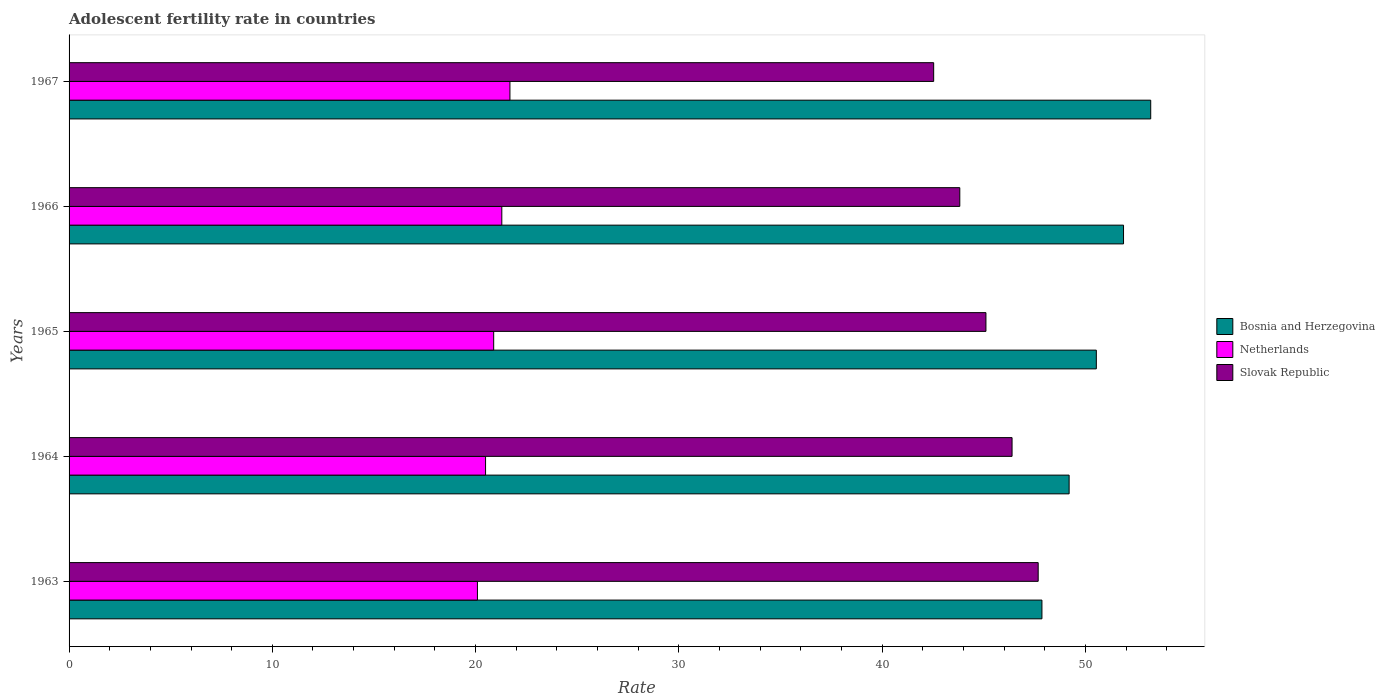Are the number of bars per tick equal to the number of legend labels?
Your response must be concise. Yes. Are the number of bars on each tick of the Y-axis equal?
Give a very brief answer. Yes. How many bars are there on the 5th tick from the bottom?
Offer a very short reply. 3. What is the label of the 4th group of bars from the top?
Your response must be concise. 1964. What is the adolescent fertility rate in Bosnia and Herzegovina in 1966?
Your answer should be compact. 51.88. Across all years, what is the maximum adolescent fertility rate in Slovak Republic?
Offer a terse response. 47.68. Across all years, what is the minimum adolescent fertility rate in Netherlands?
Keep it short and to the point. 20.09. In which year was the adolescent fertility rate in Slovak Republic maximum?
Provide a short and direct response. 1963. In which year was the adolescent fertility rate in Netherlands minimum?
Give a very brief answer. 1963. What is the total adolescent fertility rate in Bosnia and Herzegovina in the graph?
Offer a very short reply. 252.69. What is the difference between the adolescent fertility rate in Netherlands in 1963 and that in 1966?
Give a very brief answer. -1.2. What is the difference between the adolescent fertility rate in Bosnia and Herzegovina in 1966 and the adolescent fertility rate in Netherlands in 1963?
Give a very brief answer. 31.79. What is the average adolescent fertility rate in Slovak Republic per year?
Your answer should be very brief. 45.11. In the year 1964, what is the difference between the adolescent fertility rate in Bosnia and Herzegovina and adolescent fertility rate in Slovak Republic?
Provide a short and direct response. 2.81. What is the ratio of the adolescent fertility rate in Bosnia and Herzegovina in 1964 to that in 1965?
Keep it short and to the point. 0.97. Is the adolescent fertility rate in Slovak Republic in 1963 less than that in 1966?
Provide a succinct answer. No. Is the difference between the adolescent fertility rate in Bosnia and Herzegovina in 1963 and 1965 greater than the difference between the adolescent fertility rate in Slovak Republic in 1963 and 1965?
Provide a succinct answer. No. What is the difference between the highest and the second highest adolescent fertility rate in Slovak Republic?
Ensure brevity in your answer.  1.29. What is the difference between the highest and the lowest adolescent fertility rate in Slovak Republic?
Your response must be concise. 5.14. In how many years, is the adolescent fertility rate in Bosnia and Herzegovina greater than the average adolescent fertility rate in Bosnia and Herzegovina taken over all years?
Provide a succinct answer. 2. Is the sum of the adolescent fertility rate in Bosnia and Herzegovina in 1964 and 1967 greater than the maximum adolescent fertility rate in Netherlands across all years?
Your response must be concise. Yes. What does the 3rd bar from the top in 1963 represents?
Give a very brief answer. Bosnia and Herzegovina. What does the 2nd bar from the bottom in 1965 represents?
Make the answer very short. Netherlands. How many bars are there?
Offer a very short reply. 15. What is the difference between two consecutive major ticks on the X-axis?
Your response must be concise. 10. Are the values on the major ticks of X-axis written in scientific E-notation?
Provide a succinct answer. No. Does the graph contain any zero values?
Keep it short and to the point. No. Does the graph contain grids?
Your answer should be very brief. No. What is the title of the graph?
Offer a terse response. Adolescent fertility rate in countries. Does "Luxembourg" appear as one of the legend labels in the graph?
Offer a terse response. No. What is the label or title of the X-axis?
Your response must be concise. Rate. What is the Rate of Bosnia and Herzegovina in 1963?
Your answer should be compact. 47.86. What is the Rate in Netherlands in 1963?
Offer a terse response. 20.09. What is the Rate of Slovak Republic in 1963?
Provide a short and direct response. 47.68. What is the Rate of Bosnia and Herzegovina in 1964?
Your answer should be very brief. 49.2. What is the Rate in Netherlands in 1964?
Give a very brief answer. 20.49. What is the Rate in Slovak Republic in 1964?
Your answer should be very brief. 46.39. What is the Rate of Bosnia and Herzegovina in 1965?
Ensure brevity in your answer.  50.54. What is the Rate of Netherlands in 1965?
Make the answer very short. 20.89. What is the Rate in Slovak Republic in 1965?
Give a very brief answer. 45.11. What is the Rate in Bosnia and Herzegovina in 1966?
Offer a very short reply. 51.88. What is the Rate of Netherlands in 1966?
Keep it short and to the point. 21.29. What is the Rate of Slovak Republic in 1966?
Ensure brevity in your answer.  43.82. What is the Rate in Bosnia and Herzegovina in 1967?
Keep it short and to the point. 53.21. What is the Rate of Netherlands in 1967?
Give a very brief answer. 21.69. What is the Rate of Slovak Republic in 1967?
Make the answer very short. 42.54. Across all years, what is the maximum Rate in Bosnia and Herzegovina?
Offer a terse response. 53.21. Across all years, what is the maximum Rate of Netherlands?
Make the answer very short. 21.69. Across all years, what is the maximum Rate in Slovak Republic?
Provide a short and direct response. 47.68. Across all years, what is the minimum Rate in Bosnia and Herzegovina?
Ensure brevity in your answer.  47.86. Across all years, what is the minimum Rate in Netherlands?
Provide a succinct answer. 20.09. Across all years, what is the minimum Rate of Slovak Republic?
Make the answer very short. 42.54. What is the total Rate of Bosnia and Herzegovina in the graph?
Offer a very short reply. 252.69. What is the total Rate of Netherlands in the graph?
Your answer should be very brief. 104.45. What is the total Rate of Slovak Republic in the graph?
Make the answer very short. 225.53. What is the difference between the Rate in Bosnia and Herzegovina in 1963 and that in 1964?
Ensure brevity in your answer.  -1.34. What is the difference between the Rate of Netherlands in 1963 and that in 1964?
Your answer should be compact. -0.4. What is the difference between the Rate in Slovak Republic in 1963 and that in 1964?
Give a very brief answer. 1.29. What is the difference between the Rate of Bosnia and Herzegovina in 1963 and that in 1965?
Offer a very short reply. -2.68. What is the difference between the Rate in Netherlands in 1963 and that in 1965?
Your answer should be very brief. -0.8. What is the difference between the Rate in Slovak Republic in 1963 and that in 1965?
Offer a terse response. 2.57. What is the difference between the Rate in Bosnia and Herzegovina in 1963 and that in 1966?
Your response must be concise. -4.01. What is the difference between the Rate in Netherlands in 1963 and that in 1966?
Give a very brief answer. -1.2. What is the difference between the Rate of Slovak Republic in 1963 and that in 1966?
Keep it short and to the point. 3.86. What is the difference between the Rate of Bosnia and Herzegovina in 1963 and that in 1967?
Provide a short and direct response. -5.35. What is the difference between the Rate of Netherlands in 1963 and that in 1967?
Provide a succinct answer. -1.6. What is the difference between the Rate in Slovak Republic in 1963 and that in 1967?
Make the answer very short. 5.14. What is the difference between the Rate of Bosnia and Herzegovina in 1964 and that in 1965?
Provide a succinct answer. -1.34. What is the difference between the Rate of Netherlands in 1964 and that in 1965?
Make the answer very short. -0.4. What is the difference between the Rate in Slovak Republic in 1964 and that in 1965?
Your answer should be compact. 1.29. What is the difference between the Rate in Bosnia and Herzegovina in 1964 and that in 1966?
Ensure brevity in your answer.  -2.68. What is the difference between the Rate of Netherlands in 1964 and that in 1966?
Your response must be concise. -0.8. What is the difference between the Rate of Slovak Republic in 1964 and that in 1966?
Your answer should be very brief. 2.57. What is the difference between the Rate of Bosnia and Herzegovina in 1964 and that in 1967?
Provide a succinct answer. -4.01. What is the difference between the Rate of Netherlands in 1964 and that in 1967?
Your answer should be compact. -1.2. What is the difference between the Rate in Slovak Republic in 1964 and that in 1967?
Your answer should be very brief. 3.86. What is the difference between the Rate in Bosnia and Herzegovina in 1965 and that in 1966?
Make the answer very short. -1.34. What is the difference between the Rate of Netherlands in 1965 and that in 1966?
Keep it short and to the point. -0.4. What is the difference between the Rate in Slovak Republic in 1965 and that in 1966?
Keep it short and to the point. 1.29. What is the difference between the Rate of Bosnia and Herzegovina in 1965 and that in 1967?
Your answer should be compact. -2.68. What is the difference between the Rate of Netherlands in 1965 and that in 1967?
Make the answer very short. -0.8. What is the difference between the Rate in Slovak Republic in 1965 and that in 1967?
Your answer should be compact. 2.57. What is the difference between the Rate of Bosnia and Herzegovina in 1966 and that in 1967?
Offer a very short reply. -1.34. What is the difference between the Rate of Netherlands in 1966 and that in 1967?
Offer a terse response. -0.4. What is the difference between the Rate in Slovak Republic in 1966 and that in 1967?
Your response must be concise. 1.29. What is the difference between the Rate of Bosnia and Herzegovina in 1963 and the Rate of Netherlands in 1964?
Provide a short and direct response. 27.37. What is the difference between the Rate in Bosnia and Herzegovina in 1963 and the Rate in Slovak Republic in 1964?
Your answer should be compact. 1.47. What is the difference between the Rate in Netherlands in 1963 and the Rate in Slovak Republic in 1964?
Make the answer very short. -26.3. What is the difference between the Rate in Bosnia and Herzegovina in 1963 and the Rate in Netherlands in 1965?
Offer a terse response. 26.97. What is the difference between the Rate in Bosnia and Herzegovina in 1963 and the Rate in Slovak Republic in 1965?
Provide a succinct answer. 2.76. What is the difference between the Rate of Netherlands in 1963 and the Rate of Slovak Republic in 1965?
Your answer should be compact. -25.02. What is the difference between the Rate in Bosnia and Herzegovina in 1963 and the Rate in Netherlands in 1966?
Ensure brevity in your answer.  26.57. What is the difference between the Rate in Bosnia and Herzegovina in 1963 and the Rate in Slovak Republic in 1966?
Offer a terse response. 4.04. What is the difference between the Rate in Netherlands in 1963 and the Rate in Slovak Republic in 1966?
Offer a very short reply. -23.73. What is the difference between the Rate in Bosnia and Herzegovina in 1963 and the Rate in Netherlands in 1967?
Provide a succinct answer. 26.17. What is the difference between the Rate of Bosnia and Herzegovina in 1963 and the Rate of Slovak Republic in 1967?
Provide a short and direct response. 5.33. What is the difference between the Rate of Netherlands in 1963 and the Rate of Slovak Republic in 1967?
Give a very brief answer. -22.45. What is the difference between the Rate of Bosnia and Herzegovina in 1964 and the Rate of Netherlands in 1965?
Offer a terse response. 28.31. What is the difference between the Rate in Bosnia and Herzegovina in 1964 and the Rate in Slovak Republic in 1965?
Provide a succinct answer. 4.09. What is the difference between the Rate of Netherlands in 1964 and the Rate of Slovak Republic in 1965?
Ensure brevity in your answer.  -24.62. What is the difference between the Rate of Bosnia and Herzegovina in 1964 and the Rate of Netherlands in 1966?
Ensure brevity in your answer.  27.91. What is the difference between the Rate of Bosnia and Herzegovina in 1964 and the Rate of Slovak Republic in 1966?
Make the answer very short. 5.38. What is the difference between the Rate in Netherlands in 1964 and the Rate in Slovak Republic in 1966?
Offer a terse response. -23.33. What is the difference between the Rate of Bosnia and Herzegovina in 1964 and the Rate of Netherlands in 1967?
Give a very brief answer. 27.51. What is the difference between the Rate in Bosnia and Herzegovina in 1964 and the Rate in Slovak Republic in 1967?
Ensure brevity in your answer.  6.66. What is the difference between the Rate of Netherlands in 1964 and the Rate of Slovak Republic in 1967?
Offer a very short reply. -22.05. What is the difference between the Rate of Bosnia and Herzegovina in 1965 and the Rate of Netherlands in 1966?
Offer a very short reply. 29.25. What is the difference between the Rate in Bosnia and Herzegovina in 1965 and the Rate in Slovak Republic in 1966?
Provide a succinct answer. 6.72. What is the difference between the Rate in Netherlands in 1965 and the Rate in Slovak Republic in 1966?
Your answer should be compact. -22.93. What is the difference between the Rate of Bosnia and Herzegovina in 1965 and the Rate of Netherlands in 1967?
Provide a short and direct response. 28.85. What is the difference between the Rate in Bosnia and Herzegovina in 1965 and the Rate in Slovak Republic in 1967?
Provide a succinct answer. 8. What is the difference between the Rate of Netherlands in 1965 and the Rate of Slovak Republic in 1967?
Provide a short and direct response. -21.65. What is the difference between the Rate of Bosnia and Herzegovina in 1966 and the Rate of Netherlands in 1967?
Offer a very short reply. 30.19. What is the difference between the Rate in Bosnia and Herzegovina in 1966 and the Rate in Slovak Republic in 1967?
Your answer should be compact. 9.34. What is the difference between the Rate in Netherlands in 1966 and the Rate in Slovak Republic in 1967?
Your answer should be compact. -21.25. What is the average Rate in Bosnia and Herzegovina per year?
Ensure brevity in your answer.  50.54. What is the average Rate in Netherlands per year?
Ensure brevity in your answer.  20.89. What is the average Rate of Slovak Republic per year?
Keep it short and to the point. 45.11. In the year 1963, what is the difference between the Rate of Bosnia and Herzegovina and Rate of Netherlands?
Provide a short and direct response. 27.77. In the year 1963, what is the difference between the Rate in Bosnia and Herzegovina and Rate in Slovak Republic?
Make the answer very short. 0.18. In the year 1963, what is the difference between the Rate in Netherlands and Rate in Slovak Republic?
Your answer should be very brief. -27.59. In the year 1964, what is the difference between the Rate in Bosnia and Herzegovina and Rate in Netherlands?
Provide a short and direct response. 28.71. In the year 1964, what is the difference between the Rate of Bosnia and Herzegovina and Rate of Slovak Republic?
Your response must be concise. 2.81. In the year 1964, what is the difference between the Rate of Netherlands and Rate of Slovak Republic?
Your answer should be very brief. -25.9. In the year 1965, what is the difference between the Rate of Bosnia and Herzegovina and Rate of Netherlands?
Ensure brevity in your answer.  29.65. In the year 1965, what is the difference between the Rate in Bosnia and Herzegovina and Rate in Slovak Republic?
Give a very brief answer. 5.43. In the year 1965, what is the difference between the Rate in Netherlands and Rate in Slovak Republic?
Make the answer very short. -24.22. In the year 1966, what is the difference between the Rate of Bosnia and Herzegovina and Rate of Netherlands?
Keep it short and to the point. 30.59. In the year 1966, what is the difference between the Rate in Bosnia and Herzegovina and Rate in Slovak Republic?
Your response must be concise. 8.05. In the year 1966, what is the difference between the Rate of Netherlands and Rate of Slovak Republic?
Keep it short and to the point. -22.53. In the year 1967, what is the difference between the Rate of Bosnia and Herzegovina and Rate of Netherlands?
Offer a terse response. 31.52. In the year 1967, what is the difference between the Rate of Bosnia and Herzegovina and Rate of Slovak Republic?
Offer a terse response. 10.68. In the year 1967, what is the difference between the Rate in Netherlands and Rate in Slovak Republic?
Your response must be concise. -20.85. What is the ratio of the Rate of Bosnia and Herzegovina in 1963 to that in 1964?
Offer a very short reply. 0.97. What is the ratio of the Rate of Netherlands in 1963 to that in 1964?
Keep it short and to the point. 0.98. What is the ratio of the Rate of Slovak Republic in 1963 to that in 1964?
Your answer should be very brief. 1.03. What is the ratio of the Rate of Bosnia and Herzegovina in 1963 to that in 1965?
Provide a succinct answer. 0.95. What is the ratio of the Rate in Netherlands in 1963 to that in 1965?
Offer a terse response. 0.96. What is the ratio of the Rate of Slovak Republic in 1963 to that in 1965?
Provide a short and direct response. 1.06. What is the ratio of the Rate of Bosnia and Herzegovina in 1963 to that in 1966?
Your answer should be very brief. 0.92. What is the ratio of the Rate in Netherlands in 1963 to that in 1966?
Your answer should be compact. 0.94. What is the ratio of the Rate in Slovak Republic in 1963 to that in 1966?
Your answer should be compact. 1.09. What is the ratio of the Rate of Bosnia and Herzegovina in 1963 to that in 1967?
Offer a terse response. 0.9. What is the ratio of the Rate of Netherlands in 1963 to that in 1967?
Provide a short and direct response. 0.93. What is the ratio of the Rate in Slovak Republic in 1963 to that in 1967?
Offer a terse response. 1.12. What is the ratio of the Rate in Bosnia and Herzegovina in 1964 to that in 1965?
Keep it short and to the point. 0.97. What is the ratio of the Rate of Netherlands in 1964 to that in 1965?
Offer a very short reply. 0.98. What is the ratio of the Rate in Slovak Republic in 1964 to that in 1965?
Your response must be concise. 1.03. What is the ratio of the Rate in Bosnia and Herzegovina in 1964 to that in 1966?
Provide a succinct answer. 0.95. What is the ratio of the Rate in Netherlands in 1964 to that in 1966?
Keep it short and to the point. 0.96. What is the ratio of the Rate of Slovak Republic in 1964 to that in 1966?
Keep it short and to the point. 1.06. What is the ratio of the Rate in Bosnia and Herzegovina in 1964 to that in 1967?
Make the answer very short. 0.92. What is the ratio of the Rate of Netherlands in 1964 to that in 1967?
Make the answer very short. 0.94. What is the ratio of the Rate in Slovak Republic in 1964 to that in 1967?
Provide a short and direct response. 1.09. What is the ratio of the Rate of Bosnia and Herzegovina in 1965 to that in 1966?
Make the answer very short. 0.97. What is the ratio of the Rate in Netherlands in 1965 to that in 1966?
Make the answer very short. 0.98. What is the ratio of the Rate in Slovak Republic in 1965 to that in 1966?
Your answer should be compact. 1.03. What is the ratio of the Rate of Bosnia and Herzegovina in 1965 to that in 1967?
Give a very brief answer. 0.95. What is the ratio of the Rate in Netherlands in 1965 to that in 1967?
Your answer should be very brief. 0.96. What is the ratio of the Rate in Slovak Republic in 1965 to that in 1967?
Keep it short and to the point. 1.06. What is the ratio of the Rate in Bosnia and Herzegovina in 1966 to that in 1967?
Your response must be concise. 0.97. What is the ratio of the Rate in Netherlands in 1966 to that in 1967?
Your answer should be compact. 0.98. What is the ratio of the Rate of Slovak Republic in 1966 to that in 1967?
Keep it short and to the point. 1.03. What is the difference between the highest and the second highest Rate in Bosnia and Herzegovina?
Offer a terse response. 1.34. What is the difference between the highest and the second highest Rate of Netherlands?
Your answer should be very brief. 0.4. What is the difference between the highest and the second highest Rate in Slovak Republic?
Your answer should be compact. 1.29. What is the difference between the highest and the lowest Rate in Bosnia and Herzegovina?
Provide a succinct answer. 5.35. What is the difference between the highest and the lowest Rate of Netherlands?
Offer a terse response. 1.6. What is the difference between the highest and the lowest Rate of Slovak Republic?
Provide a succinct answer. 5.14. 